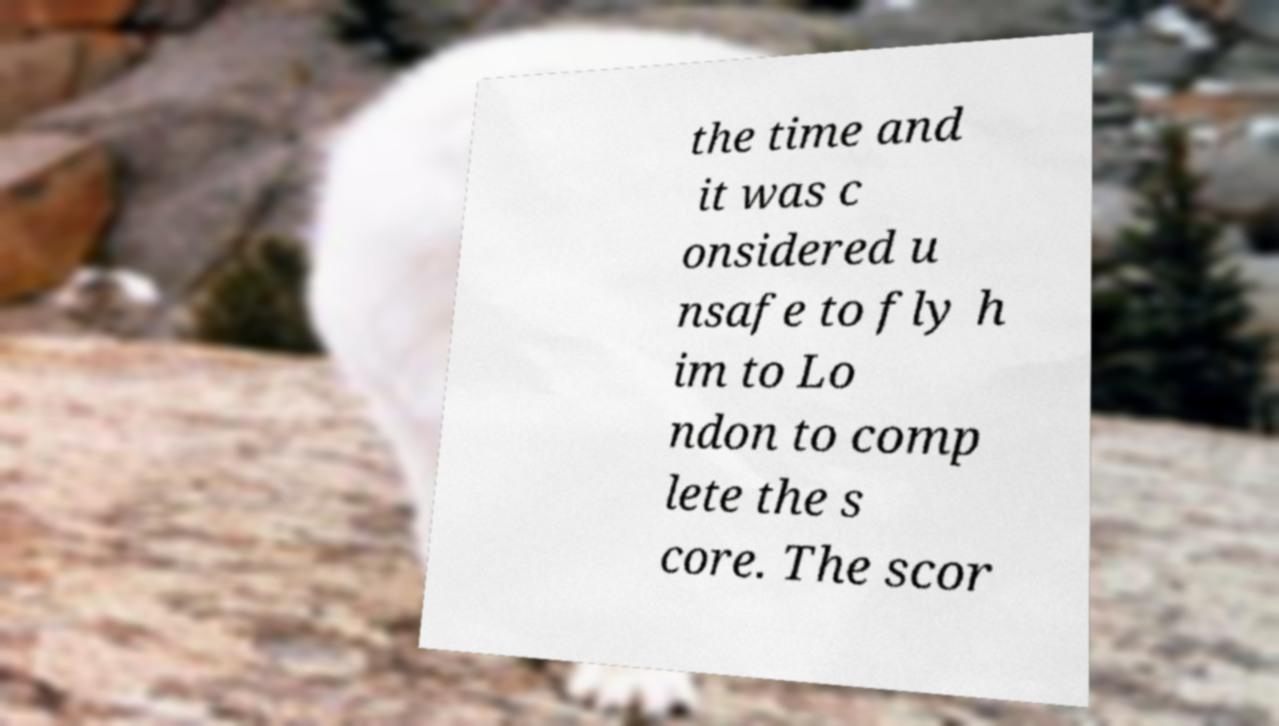Can you accurately transcribe the text from the provided image for me? the time and it was c onsidered u nsafe to fly h im to Lo ndon to comp lete the s core. The scor 